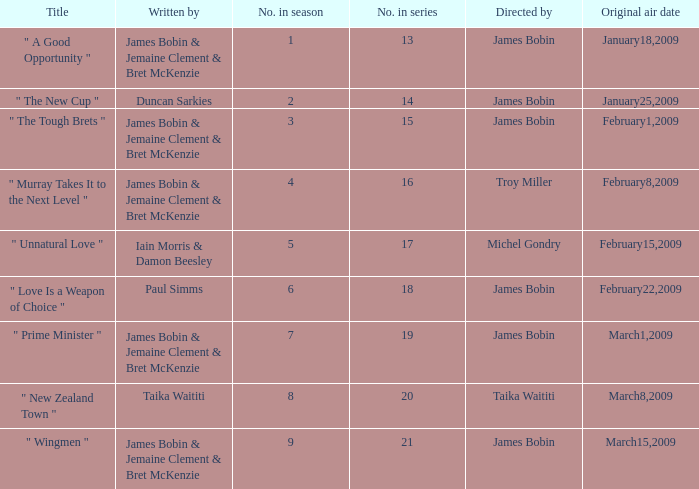 what's the title where original air date is january18,2009 " A Good Opportunity ". 